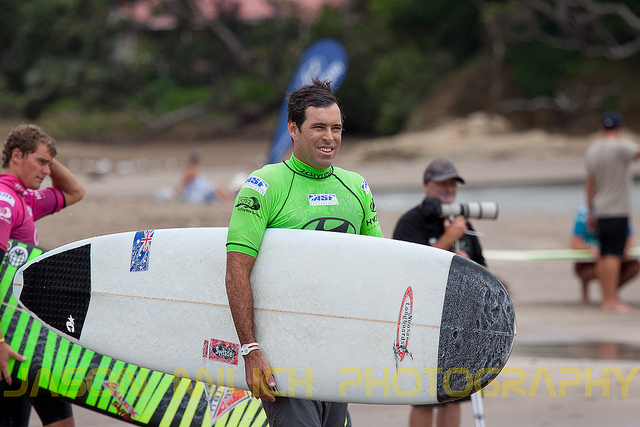Identify and read out the text in this image. PHOTOGRAPHY 